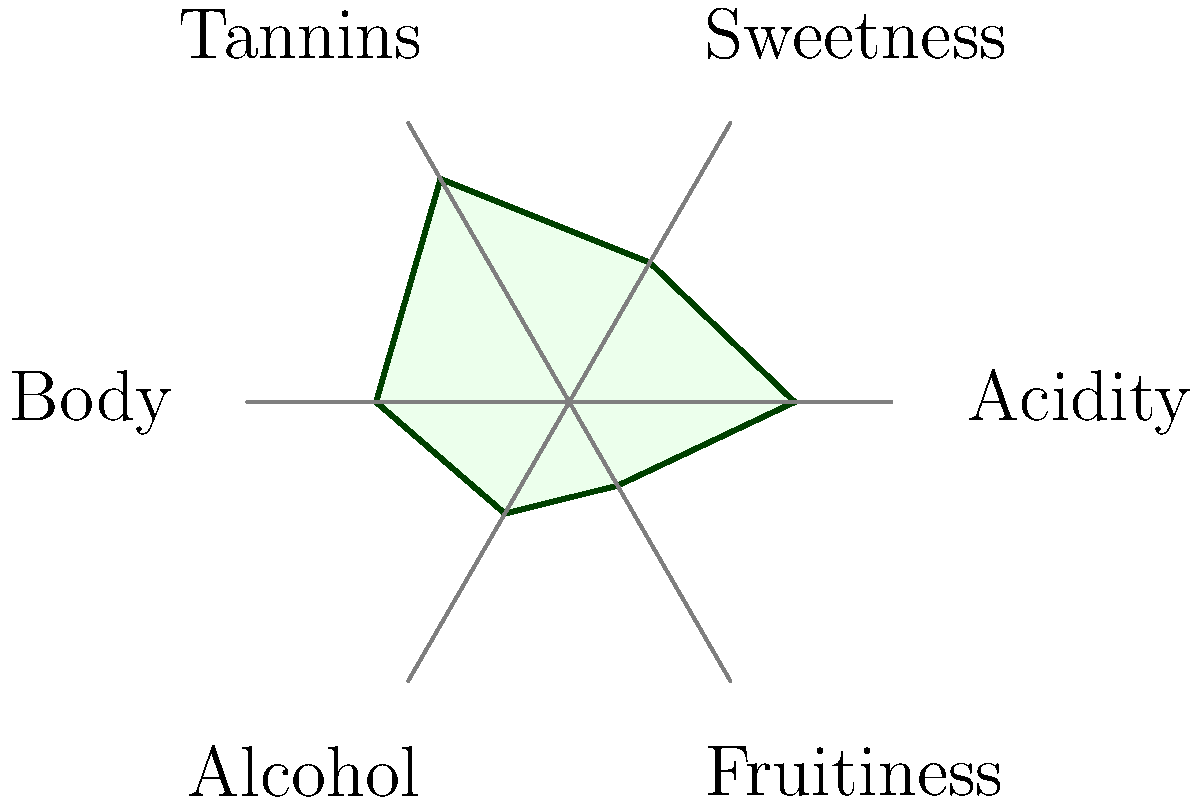Examine the circular diagram illustrating the flavor profile of a particular wine. Which characteristic is most prominent in this wine, and how does it compare to the wine's fruitiness? To answer this question, we need to analyze the circular diagram step-by-step:

1. Identify all characteristics: The diagram shows six characteristics - Acidity, Sweetness, Tannins, Body, Alcohol, and Fruitiness.

2. Determine the scale: The diagram uses a scale from 0 (center) to 10 (outer edge).

3. Assess each characteristic:
   - Acidity: 7/10
   - Sweetness: 5/10
   - Tannins: 8/10
   - Body: 6/10
   - Alcohol: 4/10
   - Fruitiness: 3/10

4. Identify the most prominent characteristic: Tannins has the highest score at 8/10.

5. Compare Tannins to Fruitiness:
   - Tannins: 8/10
   - Fruitiness: 3/10
   - Difference: 8 - 3 = 5 points

6. Quantify the comparison: Tannins are 5 points higher than Fruitiness on the 10-point scale.

Therefore, Tannins are the most prominent characteristic in this wine, scoring 5 points higher than Fruitiness on the 10-point scale.
Answer: Tannins; 5 points higher than Fruitiness 